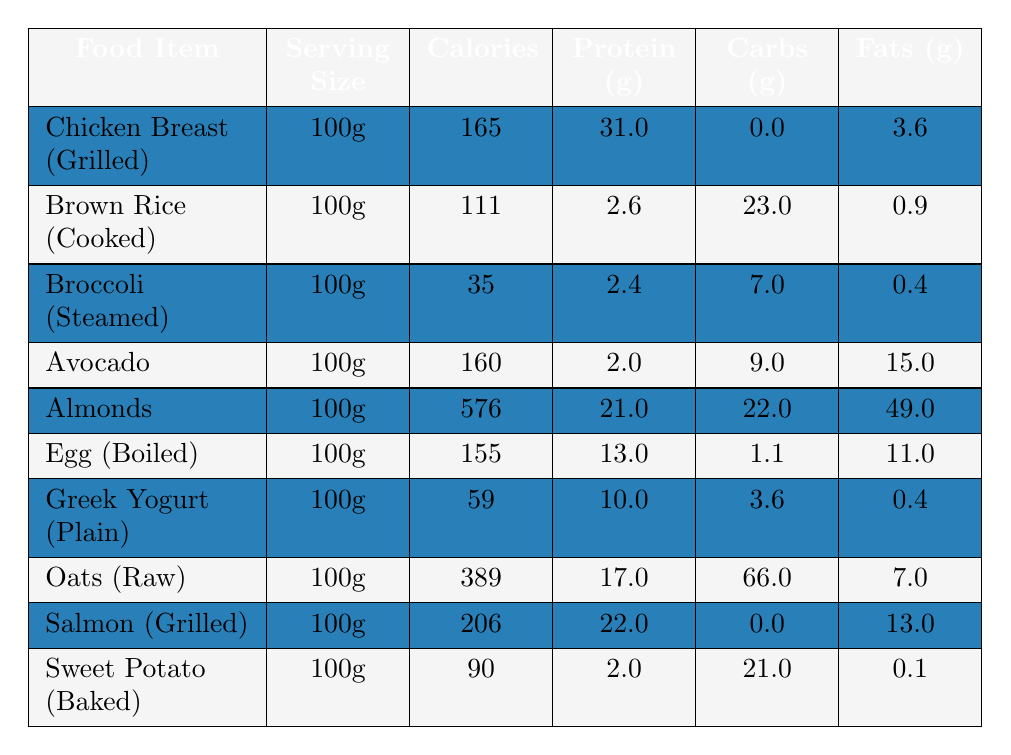What is the calorie content of Chicken Breast (Grilled)? The table lists Chicken Breast (Grilled) under the food items, showing that it has 165 calories per 100g serving.
Answer: 165 calories Which food item has the highest protein content? Looking at the protein values for each food item, Almonds have the highest protein content with 21g per 100g serving.
Answer: Almonds How many grams of carbohydrates are in Salmon (Grilled)? The table indicates that Salmon (Grilled) has 0g of carbohydrates per 100g serving, as shown in the carbohydrates column.
Answer: 0g What is the total calorie content of Oats (Raw) and Sweet Potato (Baked)? Oats (Raw) has 389 calories, and Sweet Potato (Baked) has 90 calories. Adding them gives 389 + 90 = 479 calories.
Answer: 479 calories If you eat 200g of Greek Yogurt (Plain), how many grams of protein would you consume? Greek Yogurt (Plain) contains 10g of protein per 100g serving. For 200g, you would have 10g x 2 = 20g of protein.
Answer: 20g Which food item has the lowest fat content? Comparing the fat values, Broccoli (Steamed) has the lowest with 0.4g of fats per 100g serving.
Answer: Broccoli (Steamed) What is the average calorie content of the food items listed? The total calorie content from all items is 165 + 111 + 35 + 160 + 576 + 155 + 59 + 389 + 206 + 90 = 1,876 calories. There are 10 items, so the average is 1,876 / 10 = 187.6 calories.
Answer: 187.6 calories What is the difference in fat content between Almonds and Avocado? Almonds have 49g of fat and Avocado has 15g. The difference is 49g - 15g = 34g of fat.
Answer: 34g Is it true that Brown Rice (Cooked) has more carbohydrates than Broccoli (Steamed)? Brown Rice (Cooked) has 23g of carbohydrates while Broccoli (Steamed) has 7g. Since 23g is greater than 7g, the statement is true.
Answer: Yes If you consume equal servings of Chicken Breast (Grilled) and Egg (Boiled), how much total protein would you intake? Chicken Breast (Grilled) has 31g of protein and Egg (Boiled) has 13g. Combined, that's 31g + 13g = 44g of protein.
Answer: 44g 